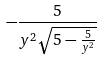Convert formula to latex. <formula><loc_0><loc_0><loc_500><loc_500>- \frac { 5 } { y ^ { 2 } \sqrt { 5 - \frac { 5 } { y ^ { 2 } } } }</formula> 